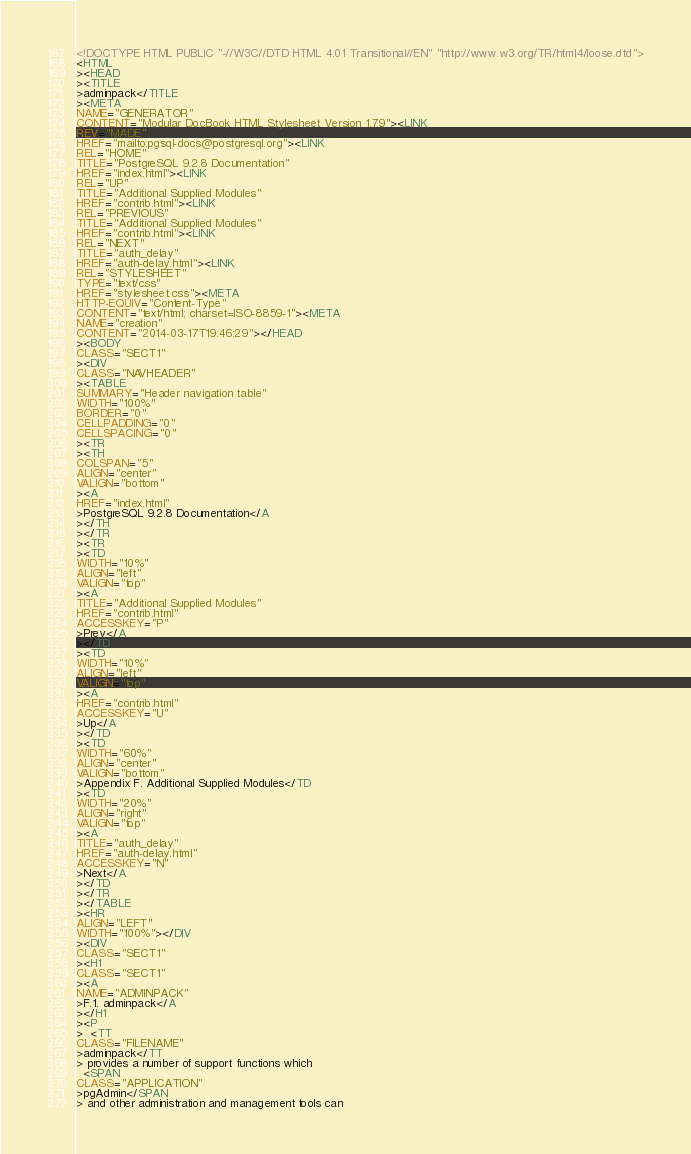<code> <loc_0><loc_0><loc_500><loc_500><_HTML_><!DOCTYPE HTML PUBLIC "-//W3C//DTD HTML 4.01 Transitional//EN" "http://www.w3.org/TR/html4/loose.dtd">
<HTML
><HEAD
><TITLE
>adminpack</TITLE
><META
NAME="GENERATOR"
CONTENT="Modular DocBook HTML Stylesheet Version 1.79"><LINK
REV="MADE"
HREF="mailto:pgsql-docs@postgresql.org"><LINK
REL="HOME"
TITLE="PostgreSQL 9.2.8 Documentation"
HREF="index.html"><LINK
REL="UP"
TITLE="Additional Supplied Modules"
HREF="contrib.html"><LINK
REL="PREVIOUS"
TITLE="Additional Supplied Modules"
HREF="contrib.html"><LINK
REL="NEXT"
TITLE="auth_delay"
HREF="auth-delay.html"><LINK
REL="STYLESHEET"
TYPE="text/css"
HREF="stylesheet.css"><META
HTTP-EQUIV="Content-Type"
CONTENT="text/html; charset=ISO-8859-1"><META
NAME="creation"
CONTENT="2014-03-17T19:46:29"></HEAD
><BODY
CLASS="SECT1"
><DIV
CLASS="NAVHEADER"
><TABLE
SUMMARY="Header navigation table"
WIDTH="100%"
BORDER="0"
CELLPADDING="0"
CELLSPACING="0"
><TR
><TH
COLSPAN="5"
ALIGN="center"
VALIGN="bottom"
><A
HREF="index.html"
>PostgreSQL 9.2.8 Documentation</A
></TH
></TR
><TR
><TD
WIDTH="10%"
ALIGN="left"
VALIGN="top"
><A
TITLE="Additional Supplied Modules"
HREF="contrib.html"
ACCESSKEY="P"
>Prev</A
></TD
><TD
WIDTH="10%"
ALIGN="left"
VALIGN="top"
><A
HREF="contrib.html"
ACCESSKEY="U"
>Up</A
></TD
><TD
WIDTH="60%"
ALIGN="center"
VALIGN="bottom"
>Appendix F. Additional Supplied Modules</TD
><TD
WIDTH="20%"
ALIGN="right"
VALIGN="top"
><A
TITLE="auth_delay"
HREF="auth-delay.html"
ACCESSKEY="N"
>Next</A
></TD
></TR
></TABLE
><HR
ALIGN="LEFT"
WIDTH="100%"></DIV
><DIV
CLASS="SECT1"
><H1
CLASS="SECT1"
><A
NAME="ADMINPACK"
>F.1. adminpack</A
></H1
><P
>  <TT
CLASS="FILENAME"
>adminpack</TT
> provides a number of support functions which
  <SPAN
CLASS="APPLICATION"
>pgAdmin</SPAN
> and other administration and management tools can</code> 